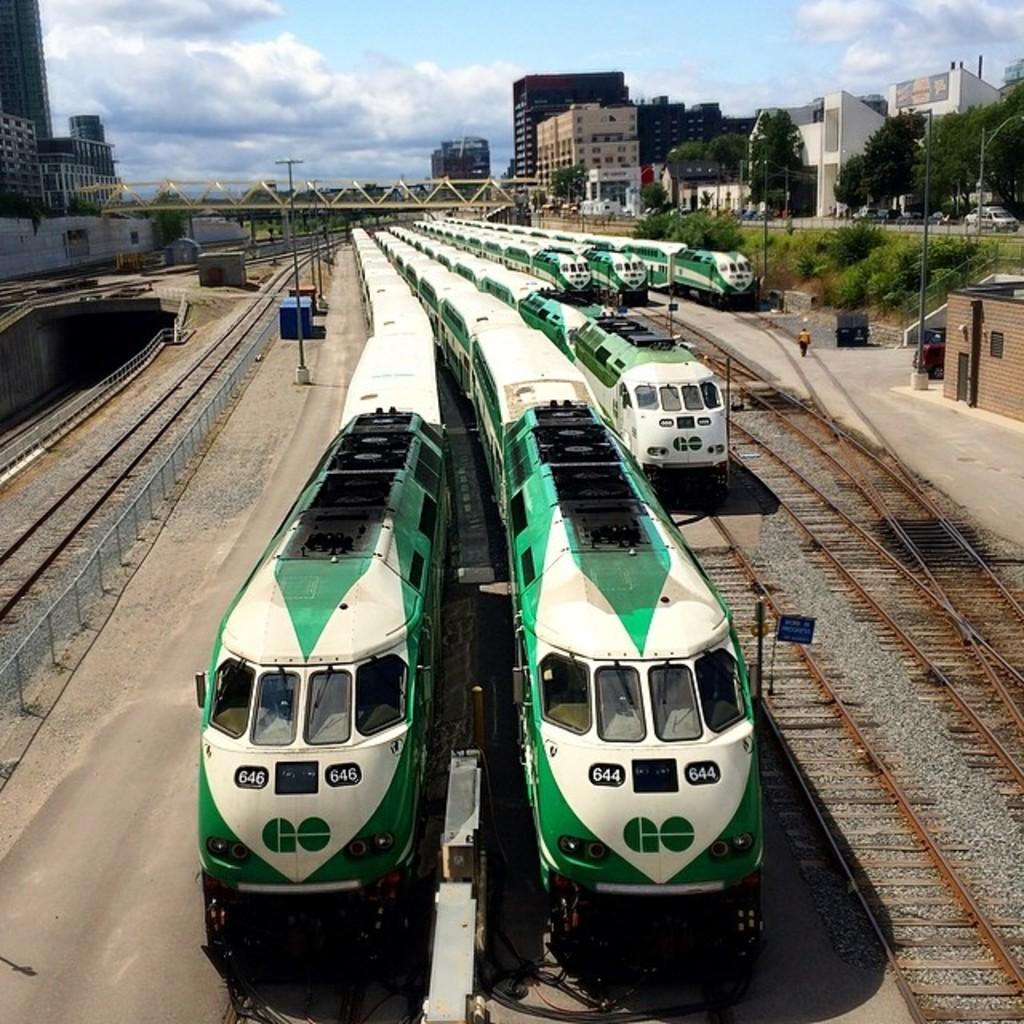Can you describe this image briefly? In this image I can see the trains on the track. The trains are in white, blue and black color. To the side of the trains I can see many poles and the shed. In the background I can see the bridge, many buildings, clouds and the sky. 